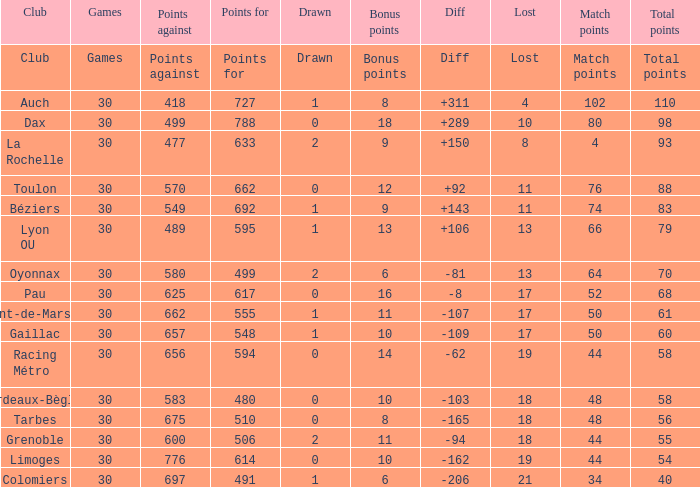What is the number of games for a club that has 34 match points? 30.0. 